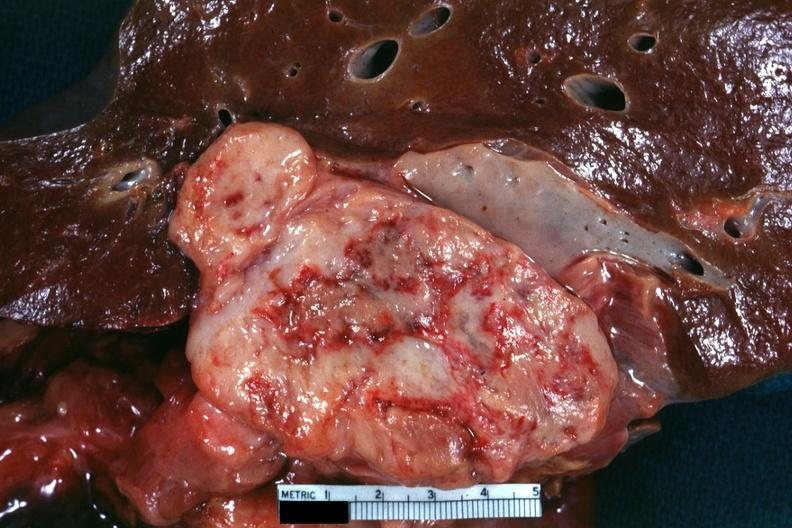what is present?
Answer the question using a single word or phrase. Retroperitoneum 